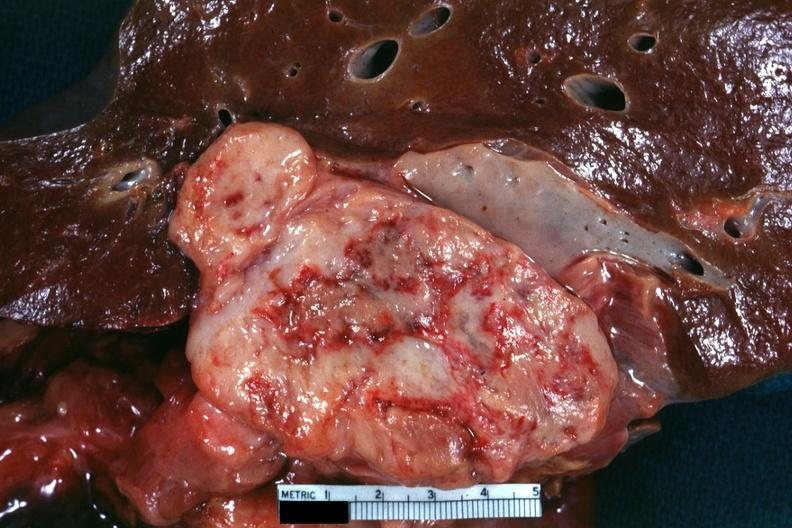what is present?
Answer the question using a single word or phrase. Retroperitoneum 